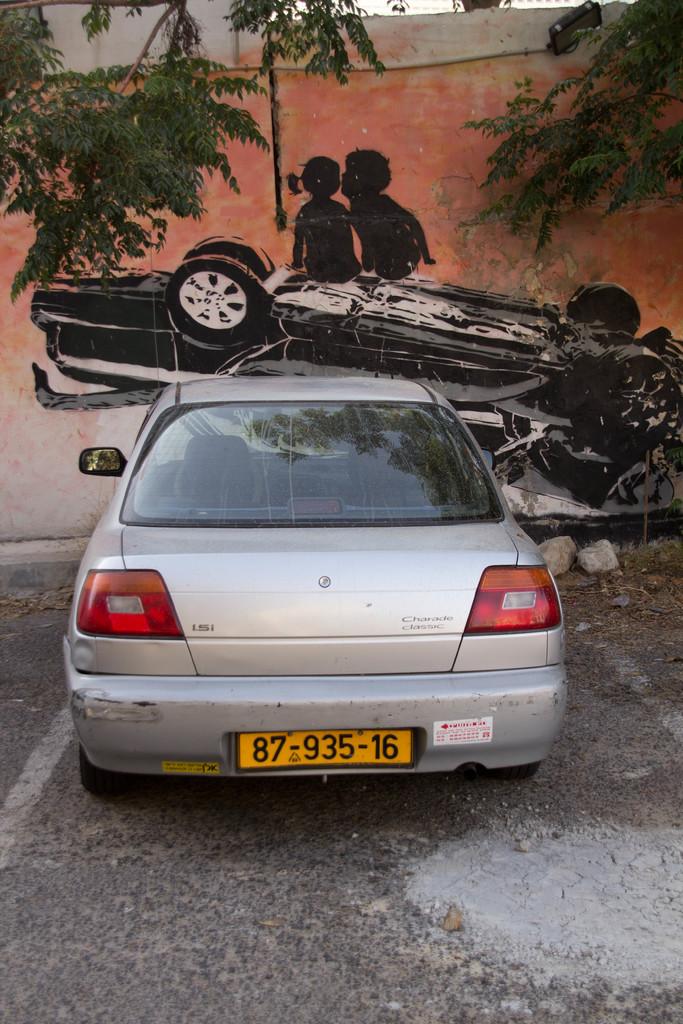What is the car's tag number?
Ensure brevity in your answer.  87-935-16. What is painted upside down on the wall?
Your response must be concise. Answering does not require reading text in the image. 